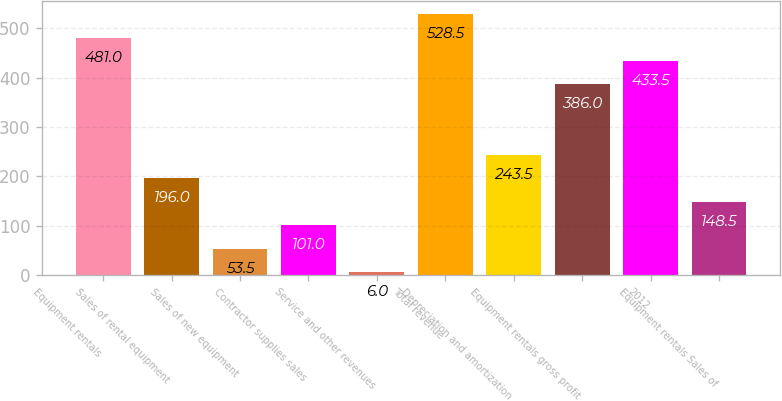Convert chart to OTSL. <chart><loc_0><loc_0><loc_500><loc_500><bar_chart><fcel>Equipment rentals<fcel>Sales of rental equipment<fcel>Sales of new equipment<fcel>Contractor supplies sales<fcel>Service and other revenues<fcel>Total revenue<fcel>Depreciation and amortization<fcel>Equipment rentals gross profit<fcel>2012<fcel>Equipment rentals Sales of<nl><fcel>481<fcel>196<fcel>53.5<fcel>101<fcel>6<fcel>528.5<fcel>243.5<fcel>386<fcel>433.5<fcel>148.5<nl></chart> 